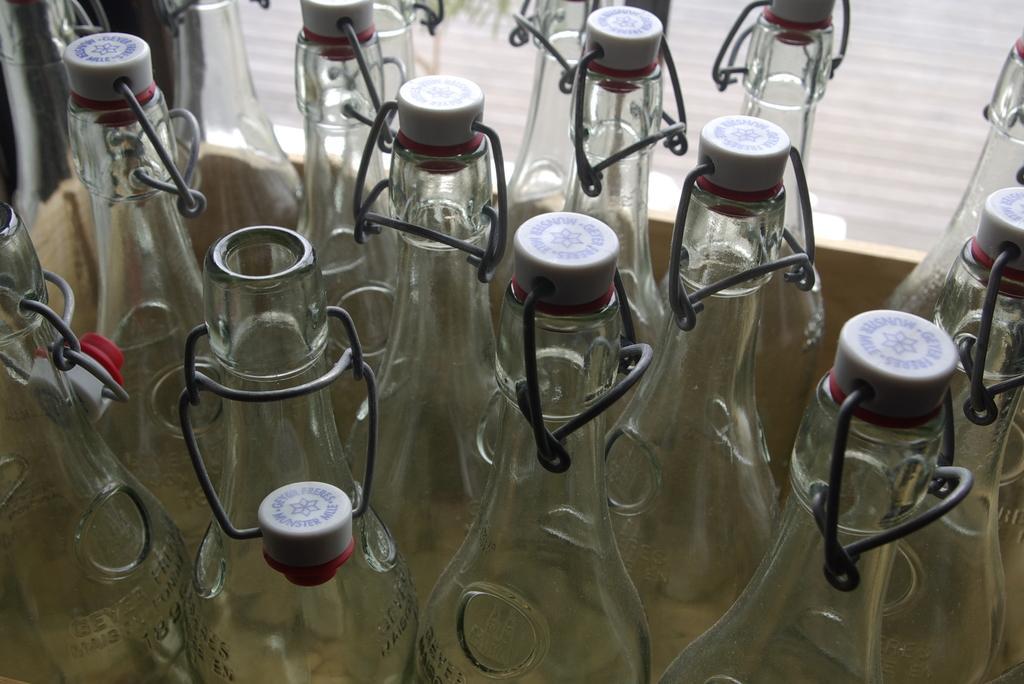Please provide a concise description of this image. In this picture there are several glass bottles , among them one of the bottle is opened. 